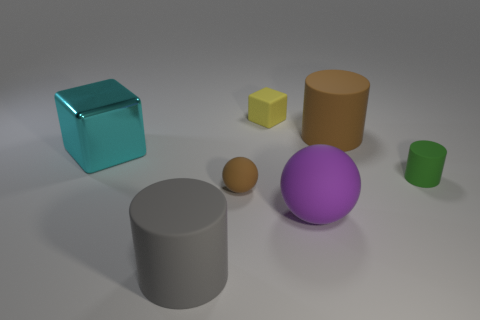Add 2 big yellow blocks. How many objects exist? 9 Subtract all blocks. How many objects are left? 5 Subtract 0 gray blocks. How many objects are left? 7 Subtract all green rubber cylinders. Subtract all small yellow blocks. How many objects are left? 5 Add 5 brown cylinders. How many brown cylinders are left? 6 Add 6 green cylinders. How many green cylinders exist? 7 